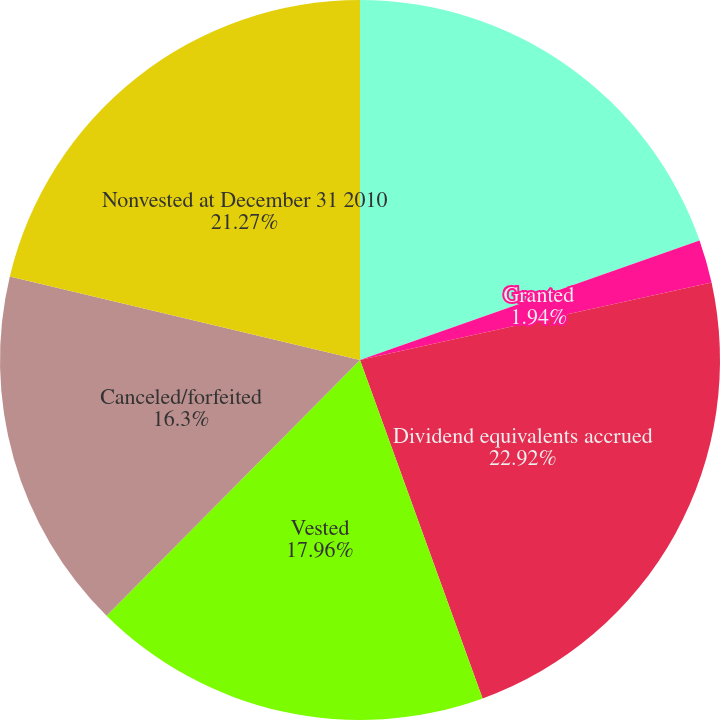Convert chart to OTSL. <chart><loc_0><loc_0><loc_500><loc_500><pie_chart><fcel>Nonvested at January 1 2010<fcel>Granted<fcel>Dividend equivalents accrued<fcel>Vested<fcel>Canceled/forfeited<fcel>Nonvested at December 31 2010<nl><fcel>19.61%<fcel>1.94%<fcel>22.92%<fcel>17.96%<fcel>16.3%<fcel>21.27%<nl></chart> 